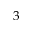<formula> <loc_0><loc_0><loc_500><loc_500>3</formula> 